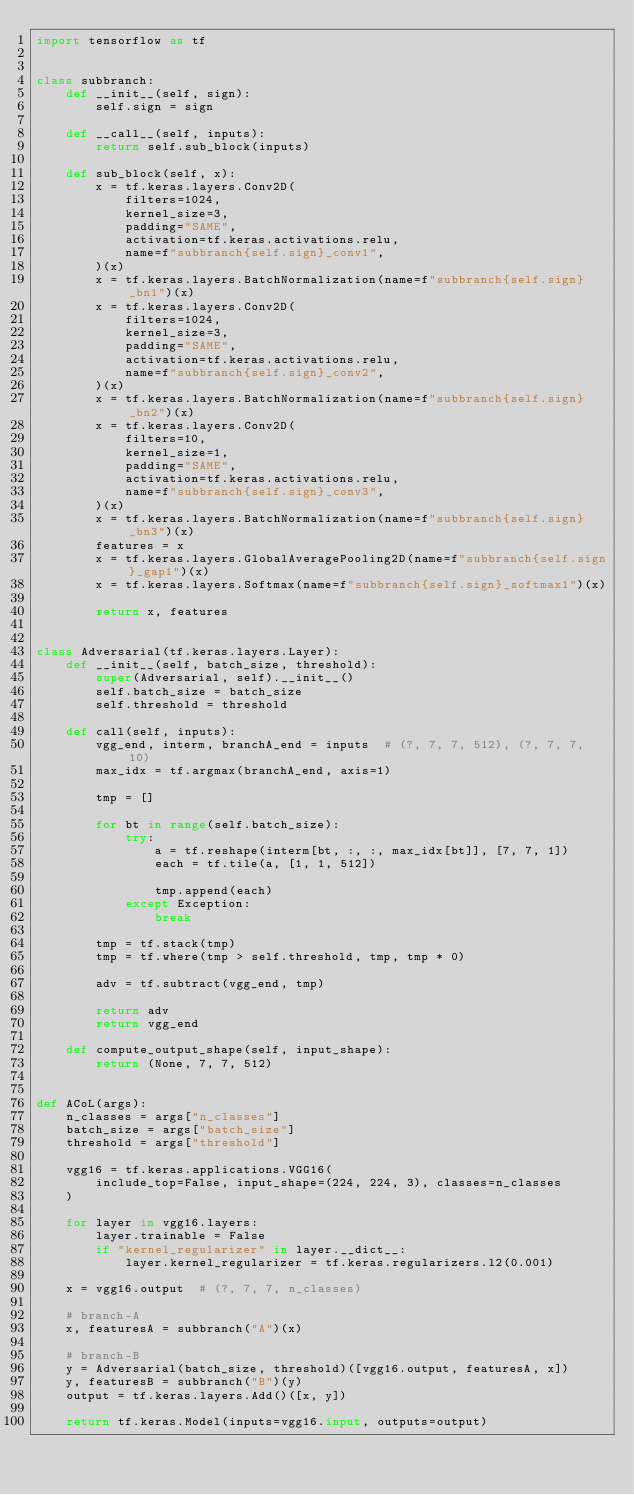<code> <loc_0><loc_0><loc_500><loc_500><_Python_>import tensorflow as tf


class subbranch:
    def __init__(self, sign):
        self.sign = sign

    def __call__(self, inputs):
        return self.sub_block(inputs)

    def sub_block(self, x):
        x = tf.keras.layers.Conv2D(
            filters=1024,
            kernel_size=3,
            padding="SAME",
            activation=tf.keras.activations.relu,
            name=f"subbranch{self.sign}_conv1",
        )(x)
        x = tf.keras.layers.BatchNormalization(name=f"subbranch{self.sign}_bn1")(x)
        x = tf.keras.layers.Conv2D(
            filters=1024,
            kernel_size=3,
            padding="SAME",
            activation=tf.keras.activations.relu,
            name=f"subbranch{self.sign}_conv2",
        )(x)
        x = tf.keras.layers.BatchNormalization(name=f"subbranch{self.sign}_bn2")(x)
        x = tf.keras.layers.Conv2D(
            filters=10,
            kernel_size=1,
            padding="SAME",
            activation=tf.keras.activations.relu,
            name=f"subbranch{self.sign}_conv3",
        )(x)
        x = tf.keras.layers.BatchNormalization(name=f"subbranch{self.sign}_bn3")(x)
        features = x
        x = tf.keras.layers.GlobalAveragePooling2D(name=f"subbranch{self.sign}_gap1")(x)
        x = tf.keras.layers.Softmax(name=f"subbranch{self.sign}_softmax1")(x)

        return x, features


class Adversarial(tf.keras.layers.Layer):
    def __init__(self, batch_size, threshold):
        super(Adversarial, self).__init__()
        self.batch_size = batch_size
        self.threshold = threshold

    def call(self, inputs):
        vgg_end, interm, branchA_end = inputs  # (?, 7, 7, 512), (?, 7, 7, 10)
        max_idx = tf.argmax(branchA_end, axis=1)

        tmp = []

        for bt in range(self.batch_size):
            try:
                a = tf.reshape(interm[bt, :, :, max_idx[bt]], [7, 7, 1])
                each = tf.tile(a, [1, 1, 512])

                tmp.append(each)
            except Exception:
                break

        tmp = tf.stack(tmp)
        tmp = tf.where(tmp > self.threshold, tmp, tmp * 0)

        adv = tf.subtract(vgg_end, tmp)

        return adv
        return vgg_end

    def compute_output_shape(self, input_shape):
        return (None, 7, 7, 512)


def ACoL(args):
    n_classes = args["n_classes"]
    batch_size = args["batch_size"]
    threshold = args["threshold"]

    vgg16 = tf.keras.applications.VGG16(
        include_top=False, input_shape=(224, 224, 3), classes=n_classes
    )

    for layer in vgg16.layers:
        layer.trainable = False
        if "kernel_regularizer" in layer.__dict__:
            layer.kernel_regularizer = tf.keras.regularizers.l2(0.001)

    x = vgg16.output  # (?, 7, 7, n_classes)

    # branch-A
    x, featuresA = subbranch("A")(x)

    # branch-B
    y = Adversarial(batch_size, threshold)([vgg16.output, featuresA, x])
    y, featuresB = subbranch("B")(y)
    output = tf.keras.layers.Add()([x, y])

    return tf.keras.Model(inputs=vgg16.input, outputs=output)
</code> 